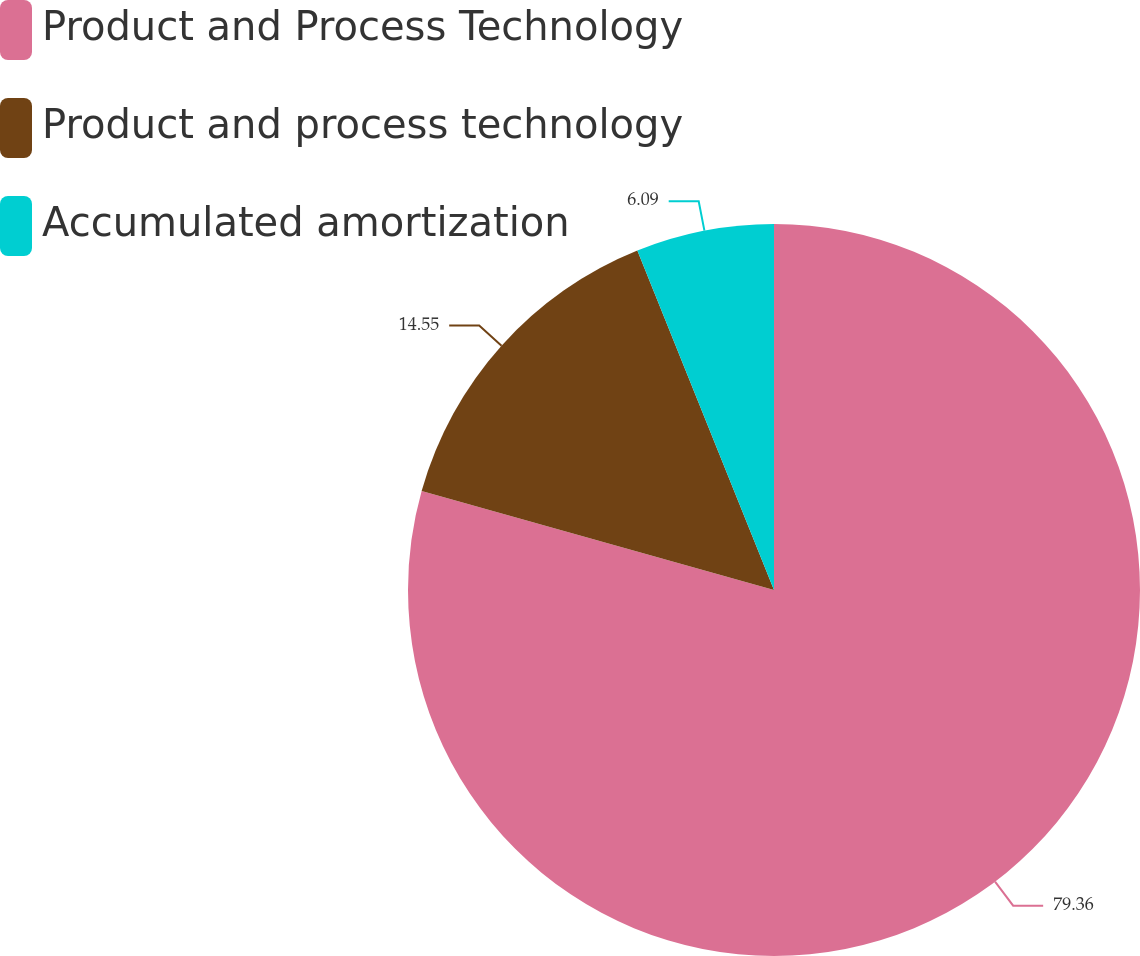<chart> <loc_0><loc_0><loc_500><loc_500><pie_chart><fcel>Product and Process Technology<fcel>Product and process technology<fcel>Accumulated amortization<nl><fcel>79.36%<fcel>14.55%<fcel>6.09%<nl></chart> 